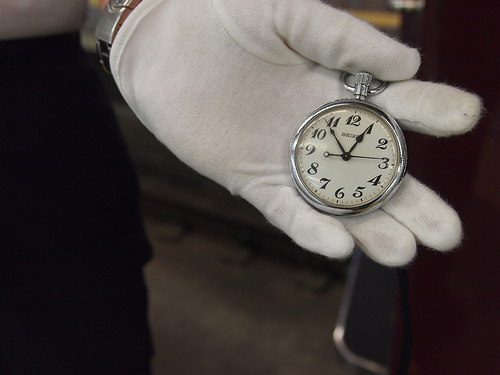<image>
Can you confirm if the watch is in front of the pants? Yes. The watch is positioned in front of the pants, appearing closer to the camera viewpoint. 